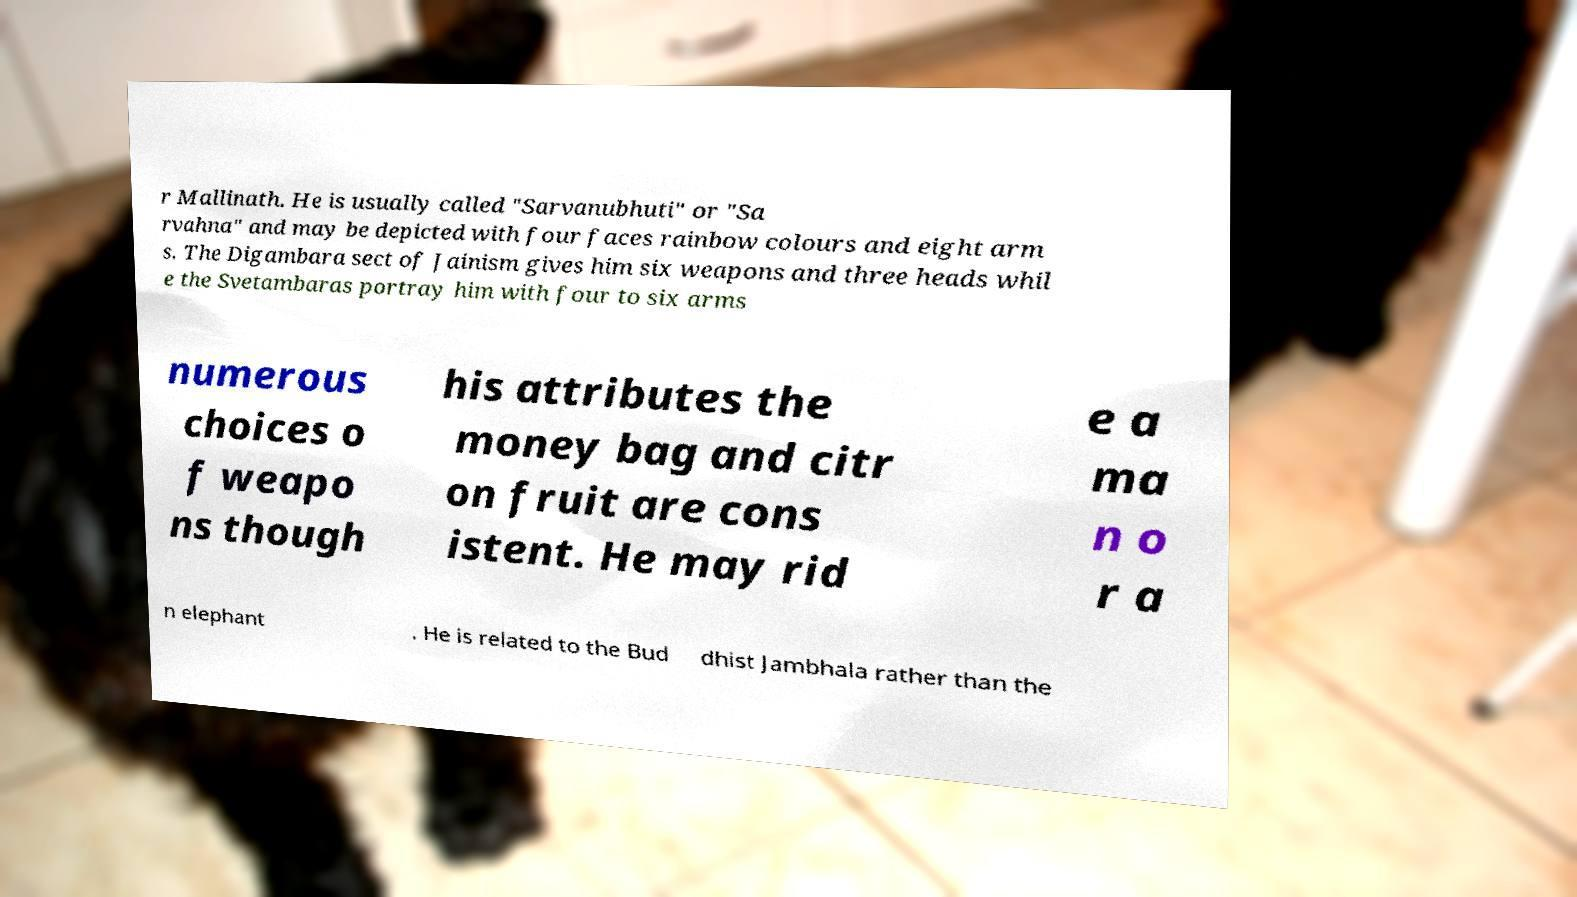For documentation purposes, I need the text within this image transcribed. Could you provide that? r Mallinath. He is usually called "Sarvanubhuti" or "Sa rvahna" and may be depicted with four faces rainbow colours and eight arm s. The Digambara sect of Jainism gives him six weapons and three heads whil e the Svetambaras portray him with four to six arms numerous choices o f weapo ns though his attributes the money bag and citr on fruit are cons istent. He may rid e a ma n o r a n elephant . He is related to the Bud dhist Jambhala rather than the 